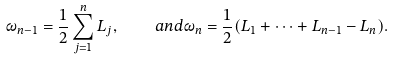Convert formula to latex. <formula><loc_0><loc_0><loc_500><loc_500>\omega _ { n - 1 } = \frac { 1 } { 2 } \sum _ { j = 1 } ^ { n } L _ { j } , \quad a n d \omega _ { n } = \frac { 1 } { 2 } ( L _ { 1 } + \dots + L _ { n - 1 } - L _ { n } ) .</formula> 